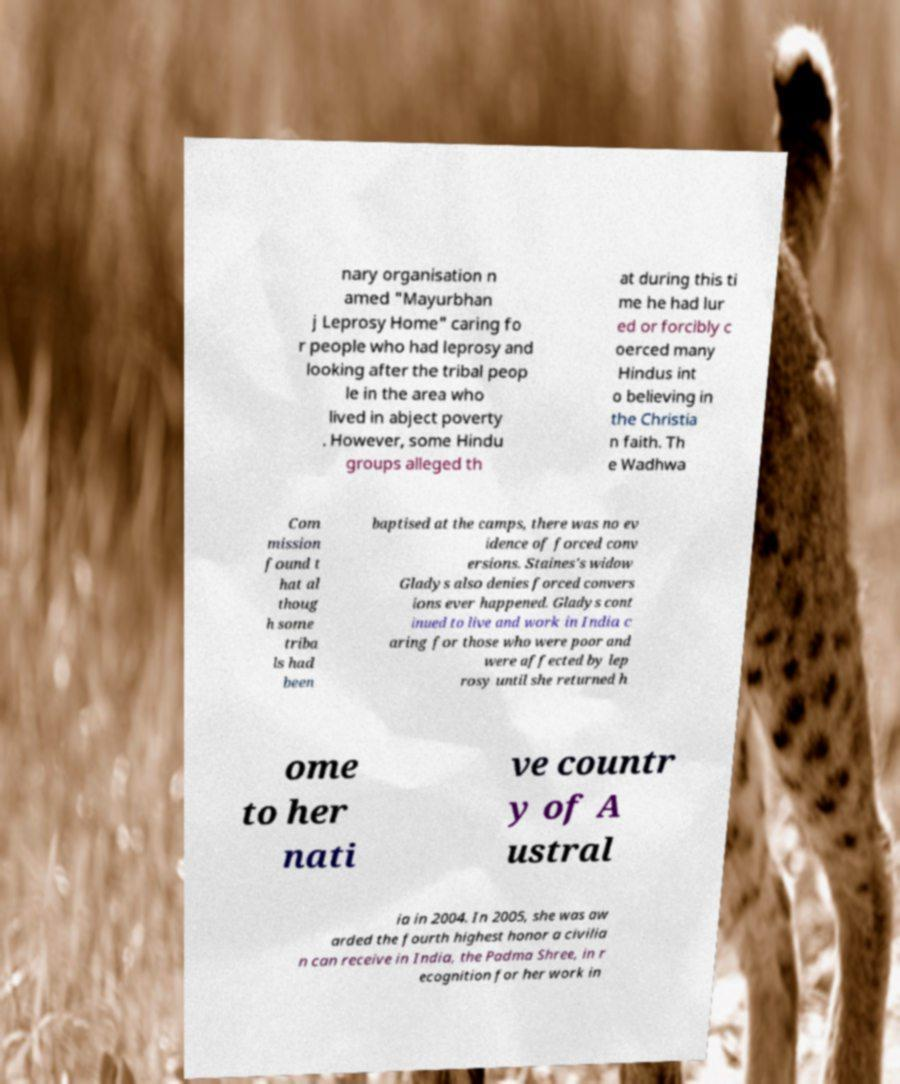Could you assist in decoding the text presented in this image and type it out clearly? nary organisation n amed "Mayurbhan j Leprosy Home" caring fo r people who had leprosy and looking after the tribal peop le in the area who lived in abject poverty . However, some Hindu groups alleged th at during this ti me he had lur ed or forcibly c oerced many Hindus int o believing in the Christia n faith. Th e Wadhwa Com mission found t hat al thoug h some triba ls had been baptised at the camps, there was no ev idence of forced conv ersions. Staines's widow Gladys also denies forced convers ions ever happened. Gladys cont inued to live and work in India c aring for those who were poor and were affected by lep rosy until she returned h ome to her nati ve countr y of A ustral ia in 2004. In 2005, she was aw arded the fourth highest honor a civilia n can receive in India, the Padma Shree, in r ecognition for her work in 